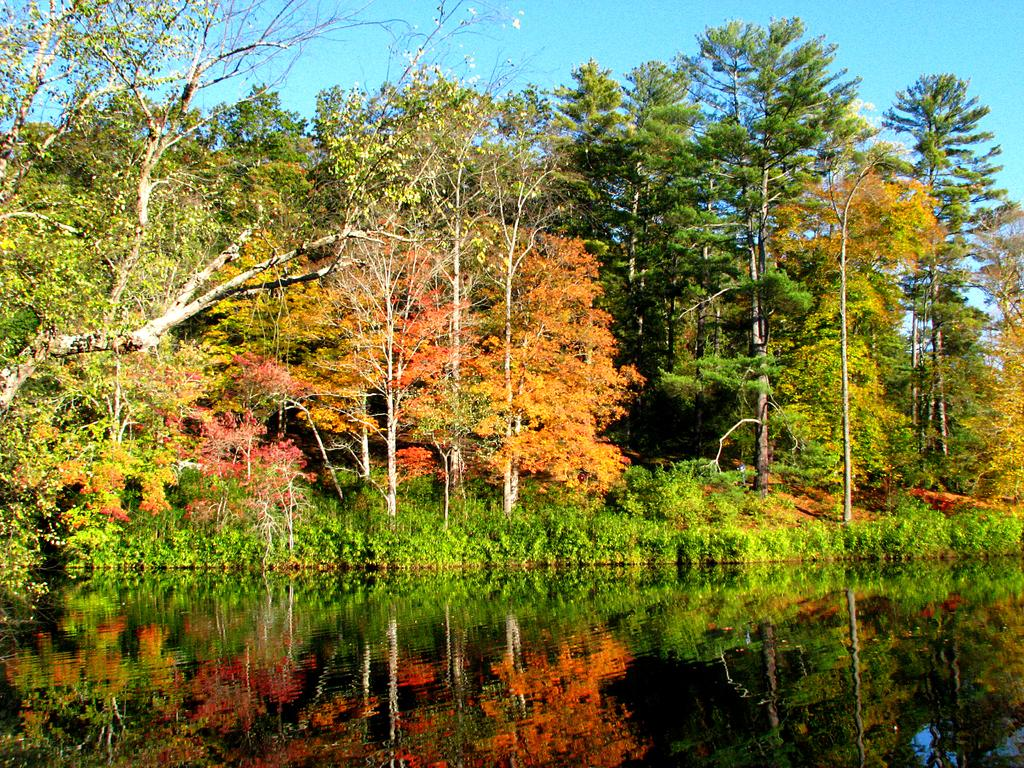What type of vegetation can be seen in the image? There are trees and plants visible in the image. What natural element is present in the image besides vegetation? There is water visible in the image. Can you describe the reflection in the water? The reflection of trees can be seen in the water. What is visible in the background of the image? The sky is visible in the background of the image. What type of dress is hanging on the tree in the image? There is no dress present in the image; it features trees, plants, water, and the sky. 